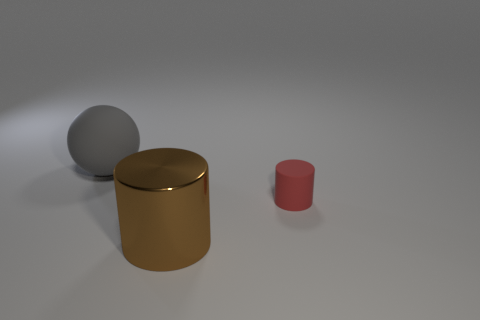Add 3 small objects. How many objects exist? 6 Subtract all cylinders. How many objects are left? 1 Subtract all large brown metallic objects. Subtract all brown metal objects. How many objects are left? 1 Add 1 brown cylinders. How many brown cylinders are left? 2 Add 3 big brown cylinders. How many big brown cylinders exist? 4 Subtract 0 cyan cylinders. How many objects are left? 3 